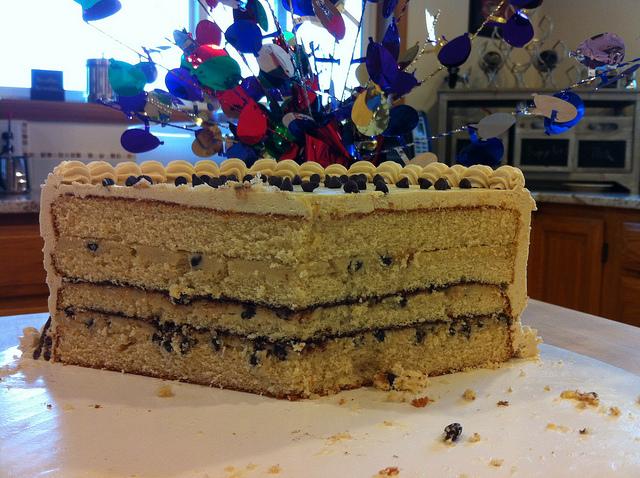Is this a whole cake?
Answer briefly. No. How many layers of cake?
Concise answer only. 4. What kind of berries on the desert?
Quick response, please. Blueberries. How many pieces of cake are left?
Be succinct. 2. 